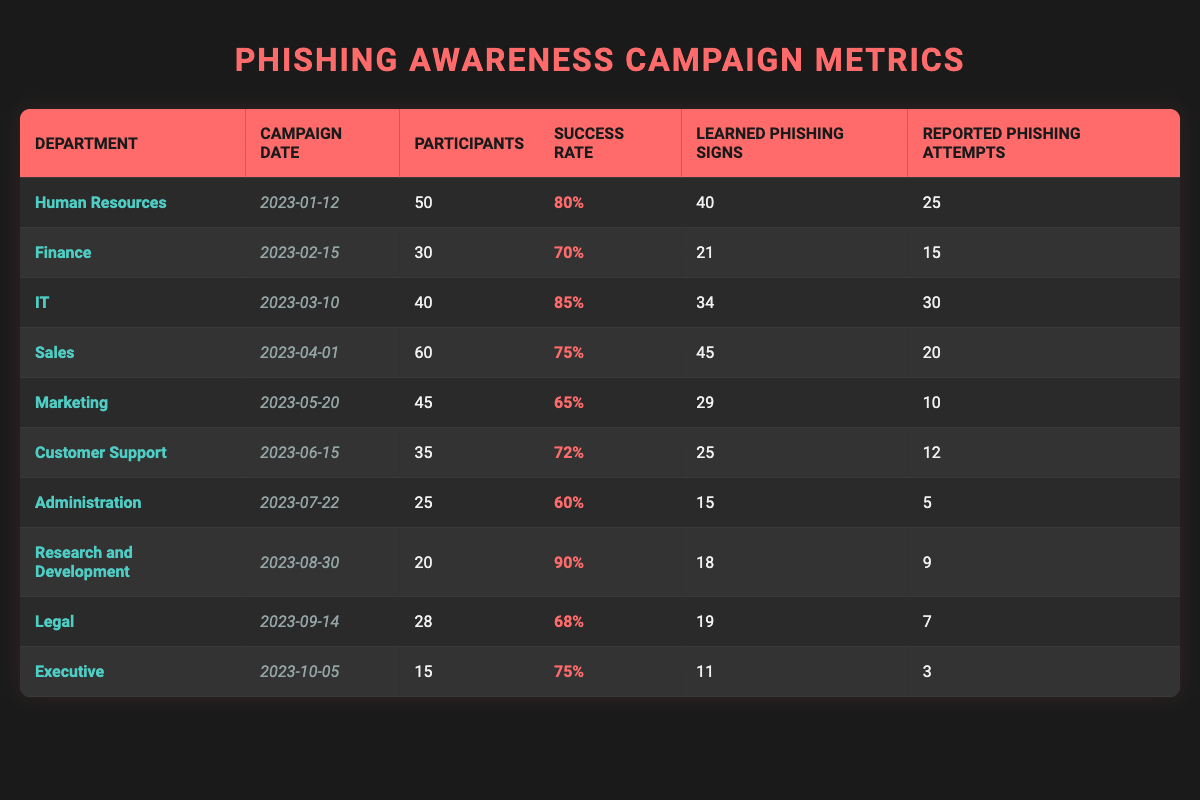What is the success rate of the IT department's phishing awareness campaign? The success rate for the IT department is directly provided in the table under the "Success Rate" column for the row corresponding to the IT department. It shows 85%.
Answer: 85% Which department had the highest success rate in phishing awareness campaigns? By examining the "Success Rate" column, I can see that the highest value is in the Research and Development department, which has a success rate of 90%.
Answer: Research and Development How many phishing attempts were reported by the Sales department? The number of reported phishing attempts for the Sales department is found in the "Reported Phishing Attempts" column of the corresponding row. It shows a total of 20 attempts.
Answer: 20 What is the average success rate of all departments in the phishing awareness campaigns? First, I sum the success rates: 80 + 70 + 85 + 75 + 65 + 72 + 60 + 90 + 68 + 75 =  795. There are 10 departments, so the average success rate is 795/10 = 79.5%.
Answer: 79.5% Did the Administration department have a higher success rate than the Marketing department? By comparing the success rates: Administration has 60% and Marketing has 65%. Since 60% is less than 65%, the Administration department did not have a higher success rate.
Answer: No What is the total number of participants in the phishing awareness campaigns conducted in 2023? To find the total number of participants, I sum the participants from all departments: 50 + 30 + 40 + 60 + 45 + 35 + 25 + 20 + 28 + 15 =  378.
Answer: 378 How many departments reported more than 20 phishing attempts? I need to refer to the "Reported Phishing Attempts" column and count the entries greater than 20. The departments with more than 20 attempts are Human Resources (25), IT (30), Sales (20), and Customer Support (12), giving a total of 4 departments.
Answer: 4 Which department had the lowest success rate, and what was that rate? The lowest success rate can be found by reviewing the "Success Rate" column and identifying the minimum value. The Administration department has the lowest success rate at 60%.
Answer: Administration, 60% If the Human Resources department had 50 participants and reported 25 phishing attempts, what percentage of participants reported phishing attempts? To find the percentage of participants who reported phishing attempts, I divide the reported phishing attempts (25) by the total participants (50) and then multiply by 100: (25/50) * 100 = 50%.
Answer: 50% 